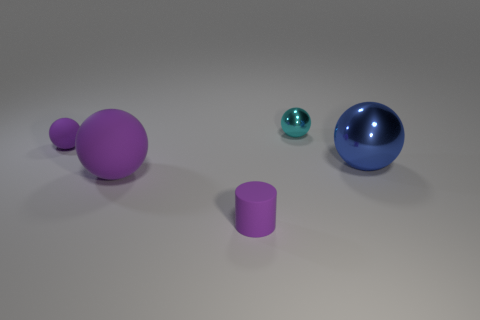Add 3 gray metallic spheres. How many objects exist? 8 Subtract all green spheres. Subtract all red cylinders. How many spheres are left? 4 Subtract all spheres. How many objects are left? 1 Add 5 tiny gray objects. How many tiny gray objects exist? 5 Subtract 0 gray spheres. How many objects are left? 5 Subtract all tiny red rubber objects. Subtract all tiny purple objects. How many objects are left? 3 Add 3 big blue objects. How many big blue objects are left? 4 